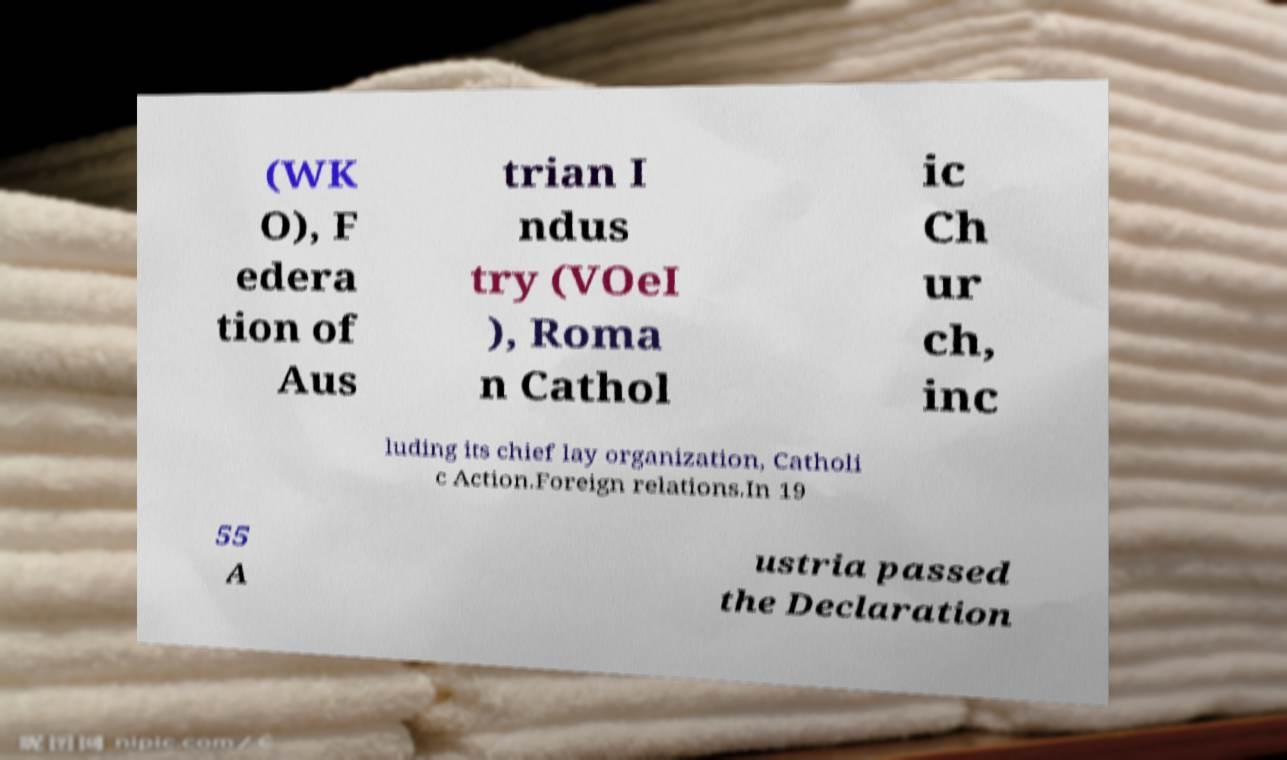There's text embedded in this image that I need extracted. Can you transcribe it verbatim? (WK O), F edera tion of Aus trian I ndus try (VOeI ), Roma n Cathol ic Ch ur ch, inc luding its chief lay organization, Catholi c Action.Foreign relations.In 19 55 A ustria passed the Declaration 